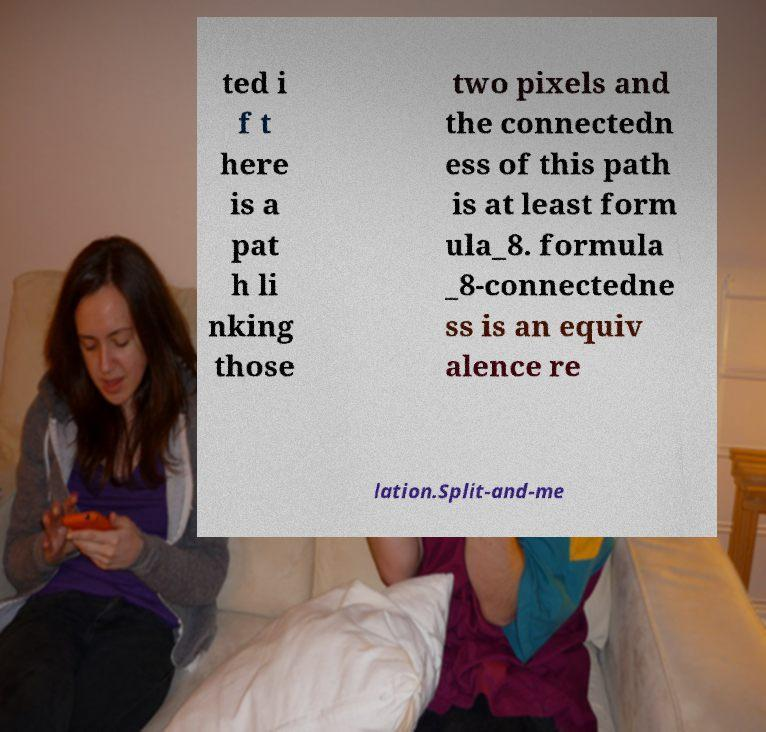What messages or text are displayed in this image? I need them in a readable, typed format. ted i f t here is a pat h li nking those two pixels and the connectedn ess of this path is at least form ula_8. formula _8-connectedne ss is an equiv alence re lation.Split-and-me 